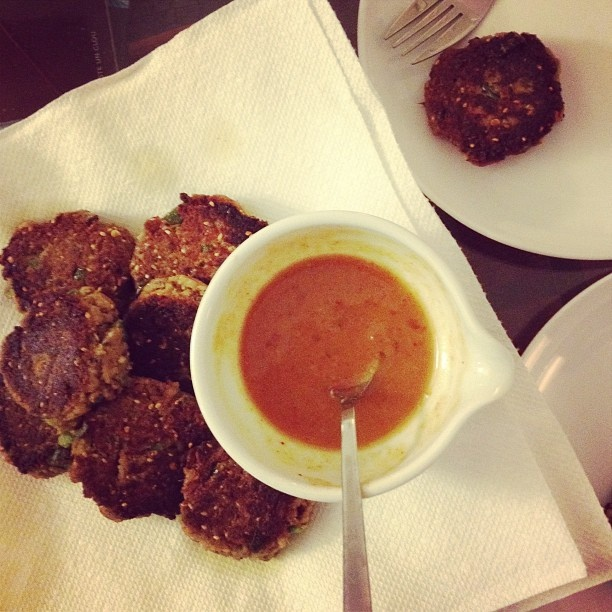Describe the objects in this image and their specific colors. I can see dining table in tan, maroon, black, and lightyellow tones, cup in black, khaki, brown, and tan tones, bowl in black, khaki, brown, and tan tones, cake in black, maroon, and brown tones, and cake in black, maroon, and brown tones in this image. 